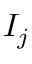<formula> <loc_0><loc_0><loc_500><loc_500>I _ { j }</formula> 